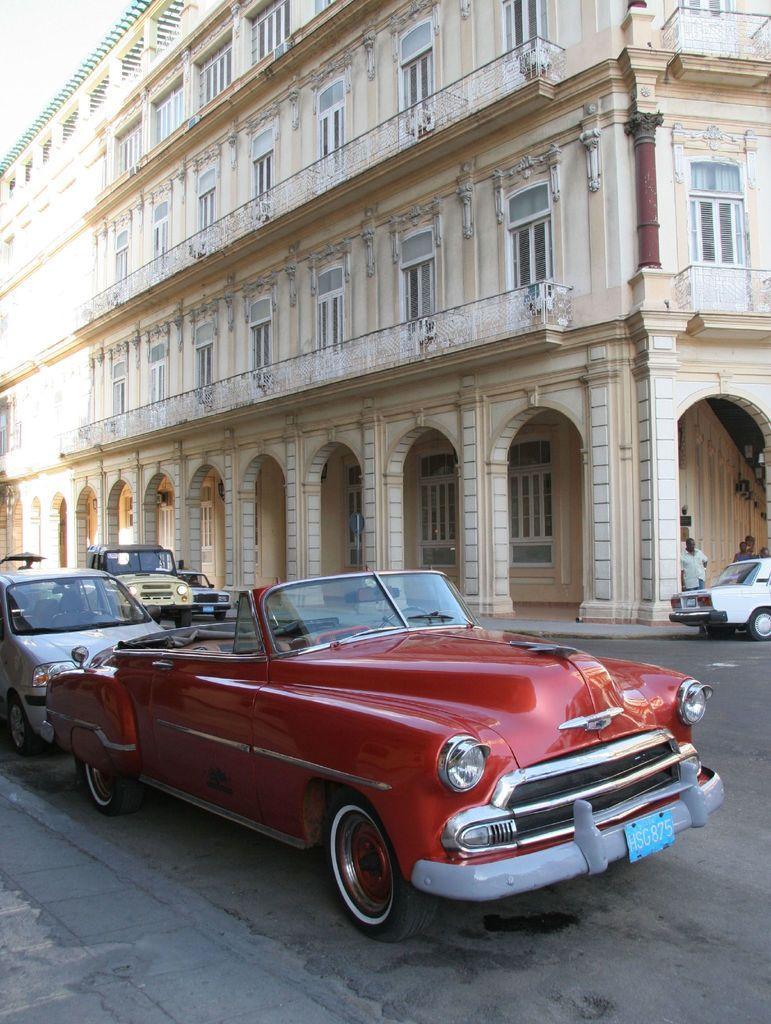How would you summarize this image in a sentence or two? In this image we can see some vehicles on the road and there are few people standing near the car. We can see a building in the background. 